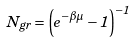<formula> <loc_0><loc_0><loc_500><loc_500>N _ { g r } = \left ( e ^ { - \beta \mu } - 1 \right ) ^ { - 1 }</formula> 